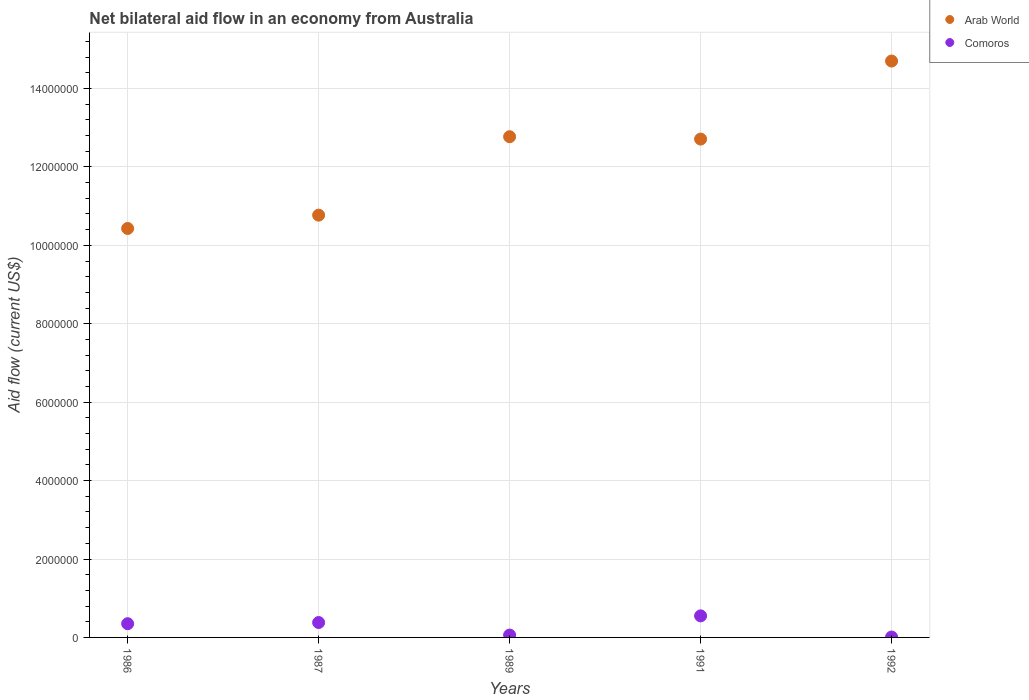How many different coloured dotlines are there?
Your answer should be very brief. 2. Across all years, what is the maximum net bilateral aid flow in Comoros?
Your answer should be compact. 5.50e+05. In which year was the net bilateral aid flow in Arab World maximum?
Make the answer very short. 1992. What is the total net bilateral aid flow in Comoros in the graph?
Provide a short and direct response. 1.35e+06. What is the difference between the net bilateral aid flow in Arab World in 1987 and that in 1989?
Offer a terse response. -2.00e+06. What is the difference between the net bilateral aid flow in Comoros in 1991 and the net bilateral aid flow in Arab World in 1986?
Your answer should be compact. -9.88e+06. What is the average net bilateral aid flow in Arab World per year?
Ensure brevity in your answer.  1.23e+07. In the year 1989, what is the difference between the net bilateral aid flow in Arab World and net bilateral aid flow in Comoros?
Give a very brief answer. 1.27e+07. What is the ratio of the net bilateral aid flow in Arab World in 1986 to that in 1989?
Provide a succinct answer. 0.82. Is the difference between the net bilateral aid flow in Arab World in 1987 and 1989 greater than the difference between the net bilateral aid flow in Comoros in 1987 and 1989?
Make the answer very short. No. What is the difference between the highest and the second highest net bilateral aid flow in Comoros?
Give a very brief answer. 1.70e+05. What is the difference between the highest and the lowest net bilateral aid flow in Arab World?
Your answer should be very brief. 4.27e+06. Is the net bilateral aid flow in Arab World strictly greater than the net bilateral aid flow in Comoros over the years?
Your answer should be very brief. Yes. How many years are there in the graph?
Give a very brief answer. 5. What is the difference between two consecutive major ticks on the Y-axis?
Ensure brevity in your answer.  2.00e+06. Where does the legend appear in the graph?
Your answer should be compact. Top right. What is the title of the graph?
Your response must be concise. Net bilateral aid flow in an economy from Australia. What is the Aid flow (current US$) of Arab World in 1986?
Make the answer very short. 1.04e+07. What is the Aid flow (current US$) in Comoros in 1986?
Keep it short and to the point. 3.50e+05. What is the Aid flow (current US$) of Arab World in 1987?
Make the answer very short. 1.08e+07. What is the Aid flow (current US$) in Arab World in 1989?
Your answer should be compact. 1.28e+07. What is the Aid flow (current US$) in Comoros in 1989?
Your response must be concise. 6.00e+04. What is the Aid flow (current US$) in Arab World in 1991?
Ensure brevity in your answer.  1.27e+07. What is the Aid flow (current US$) in Arab World in 1992?
Offer a terse response. 1.47e+07. What is the Aid flow (current US$) of Comoros in 1992?
Provide a succinct answer. 10000. Across all years, what is the maximum Aid flow (current US$) of Arab World?
Give a very brief answer. 1.47e+07. Across all years, what is the maximum Aid flow (current US$) of Comoros?
Keep it short and to the point. 5.50e+05. Across all years, what is the minimum Aid flow (current US$) of Arab World?
Give a very brief answer. 1.04e+07. What is the total Aid flow (current US$) of Arab World in the graph?
Keep it short and to the point. 6.14e+07. What is the total Aid flow (current US$) of Comoros in the graph?
Offer a terse response. 1.35e+06. What is the difference between the Aid flow (current US$) of Comoros in 1986 and that in 1987?
Provide a succinct answer. -3.00e+04. What is the difference between the Aid flow (current US$) in Arab World in 1986 and that in 1989?
Provide a succinct answer. -2.34e+06. What is the difference between the Aid flow (current US$) in Comoros in 1986 and that in 1989?
Make the answer very short. 2.90e+05. What is the difference between the Aid flow (current US$) in Arab World in 1986 and that in 1991?
Your answer should be very brief. -2.28e+06. What is the difference between the Aid flow (current US$) of Comoros in 1986 and that in 1991?
Your answer should be very brief. -2.00e+05. What is the difference between the Aid flow (current US$) in Arab World in 1986 and that in 1992?
Your answer should be very brief. -4.27e+06. What is the difference between the Aid flow (current US$) in Arab World in 1987 and that in 1989?
Provide a short and direct response. -2.00e+06. What is the difference between the Aid flow (current US$) of Comoros in 1987 and that in 1989?
Make the answer very short. 3.20e+05. What is the difference between the Aid flow (current US$) in Arab World in 1987 and that in 1991?
Provide a succinct answer. -1.94e+06. What is the difference between the Aid flow (current US$) of Arab World in 1987 and that in 1992?
Provide a short and direct response. -3.93e+06. What is the difference between the Aid flow (current US$) in Comoros in 1987 and that in 1992?
Ensure brevity in your answer.  3.70e+05. What is the difference between the Aid flow (current US$) in Arab World in 1989 and that in 1991?
Offer a terse response. 6.00e+04. What is the difference between the Aid flow (current US$) in Comoros in 1989 and that in 1991?
Provide a succinct answer. -4.90e+05. What is the difference between the Aid flow (current US$) of Arab World in 1989 and that in 1992?
Offer a terse response. -1.93e+06. What is the difference between the Aid flow (current US$) in Arab World in 1991 and that in 1992?
Your answer should be compact. -1.99e+06. What is the difference between the Aid flow (current US$) in Comoros in 1991 and that in 1992?
Give a very brief answer. 5.40e+05. What is the difference between the Aid flow (current US$) in Arab World in 1986 and the Aid flow (current US$) in Comoros in 1987?
Your response must be concise. 1.00e+07. What is the difference between the Aid flow (current US$) in Arab World in 1986 and the Aid flow (current US$) in Comoros in 1989?
Give a very brief answer. 1.04e+07. What is the difference between the Aid flow (current US$) of Arab World in 1986 and the Aid flow (current US$) of Comoros in 1991?
Your response must be concise. 9.88e+06. What is the difference between the Aid flow (current US$) in Arab World in 1986 and the Aid flow (current US$) in Comoros in 1992?
Offer a terse response. 1.04e+07. What is the difference between the Aid flow (current US$) of Arab World in 1987 and the Aid flow (current US$) of Comoros in 1989?
Provide a succinct answer. 1.07e+07. What is the difference between the Aid flow (current US$) of Arab World in 1987 and the Aid flow (current US$) of Comoros in 1991?
Give a very brief answer. 1.02e+07. What is the difference between the Aid flow (current US$) of Arab World in 1987 and the Aid flow (current US$) of Comoros in 1992?
Offer a terse response. 1.08e+07. What is the difference between the Aid flow (current US$) of Arab World in 1989 and the Aid flow (current US$) of Comoros in 1991?
Offer a very short reply. 1.22e+07. What is the difference between the Aid flow (current US$) in Arab World in 1989 and the Aid flow (current US$) in Comoros in 1992?
Make the answer very short. 1.28e+07. What is the difference between the Aid flow (current US$) of Arab World in 1991 and the Aid flow (current US$) of Comoros in 1992?
Give a very brief answer. 1.27e+07. What is the average Aid flow (current US$) in Arab World per year?
Provide a short and direct response. 1.23e+07. What is the average Aid flow (current US$) of Comoros per year?
Ensure brevity in your answer.  2.70e+05. In the year 1986, what is the difference between the Aid flow (current US$) of Arab World and Aid flow (current US$) of Comoros?
Provide a short and direct response. 1.01e+07. In the year 1987, what is the difference between the Aid flow (current US$) of Arab World and Aid flow (current US$) of Comoros?
Offer a very short reply. 1.04e+07. In the year 1989, what is the difference between the Aid flow (current US$) of Arab World and Aid flow (current US$) of Comoros?
Provide a succinct answer. 1.27e+07. In the year 1991, what is the difference between the Aid flow (current US$) of Arab World and Aid flow (current US$) of Comoros?
Give a very brief answer. 1.22e+07. In the year 1992, what is the difference between the Aid flow (current US$) of Arab World and Aid flow (current US$) of Comoros?
Give a very brief answer. 1.47e+07. What is the ratio of the Aid flow (current US$) of Arab World in 1986 to that in 1987?
Offer a terse response. 0.97. What is the ratio of the Aid flow (current US$) of Comoros in 1986 to that in 1987?
Your answer should be very brief. 0.92. What is the ratio of the Aid flow (current US$) in Arab World in 1986 to that in 1989?
Keep it short and to the point. 0.82. What is the ratio of the Aid flow (current US$) of Comoros in 1986 to that in 1989?
Ensure brevity in your answer.  5.83. What is the ratio of the Aid flow (current US$) of Arab World in 1986 to that in 1991?
Give a very brief answer. 0.82. What is the ratio of the Aid flow (current US$) of Comoros in 1986 to that in 1991?
Offer a terse response. 0.64. What is the ratio of the Aid flow (current US$) of Arab World in 1986 to that in 1992?
Your answer should be very brief. 0.71. What is the ratio of the Aid flow (current US$) in Comoros in 1986 to that in 1992?
Give a very brief answer. 35. What is the ratio of the Aid flow (current US$) of Arab World in 1987 to that in 1989?
Ensure brevity in your answer.  0.84. What is the ratio of the Aid flow (current US$) in Comoros in 1987 to that in 1989?
Offer a terse response. 6.33. What is the ratio of the Aid flow (current US$) of Arab World in 1987 to that in 1991?
Provide a succinct answer. 0.85. What is the ratio of the Aid flow (current US$) in Comoros in 1987 to that in 1991?
Keep it short and to the point. 0.69. What is the ratio of the Aid flow (current US$) of Arab World in 1987 to that in 1992?
Make the answer very short. 0.73. What is the ratio of the Aid flow (current US$) in Arab World in 1989 to that in 1991?
Ensure brevity in your answer.  1. What is the ratio of the Aid flow (current US$) in Comoros in 1989 to that in 1991?
Give a very brief answer. 0.11. What is the ratio of the Aid flow (current US$) of Arab World in 1989 to that in 1992?
Your response must be concise. 0.87. What is the ratio of the Aid flow (current US$) of Arab World in 1991 to that in 1992?
Make the answer very short. 0.86. What is the ratio of the Aid flow (current US$) in Comoros in 1991 to that in 1992?
Provide a short and direct response. 55. What is the difference between the highest and the second highest Aid flow (current US$) in Arab World?
Provide a succinct answer. 1.93e+06. What is the difference between the highest and the second highest Aid flow (current US$) in Comoros?
Your response must be concise. 1.70e+05. What is the difference between the highest and the lowest Aid flow (current US$) of Arab World?
Provide a succinct answer. 4.27e+06. What is the difference between the highest and the lowest Aid flow (current US$) in Comoros?
Keep it short and to the point. 5.40e+05. 